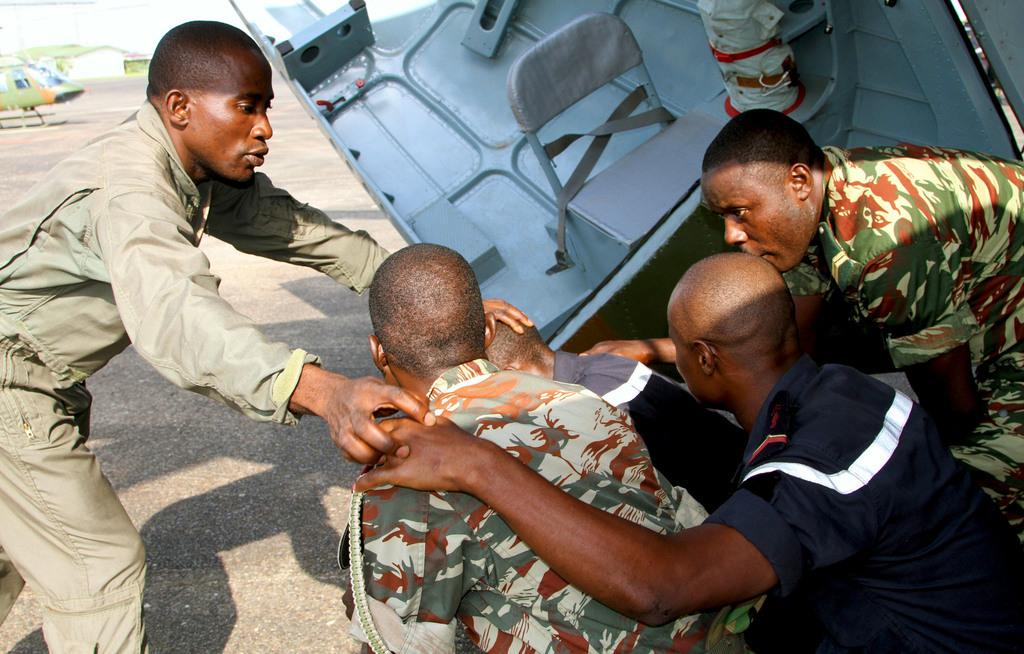How many people are in the image? There are five men in the image. What can be seen on the left side of the image? There is a green helicopter on the left side of the image. What type of structure is visible in the background of the image? There appears to be a house in the background of the image. What type of drum can be heard playing in the image? There is no drum present in the image, and therefore no sound can be heard. 